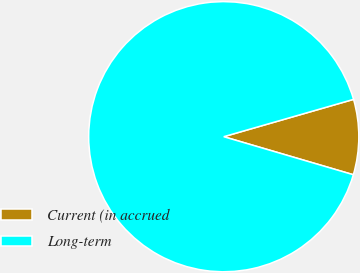<chart> <loc_0><loc_0><loc_500><loc_500><pie_chart><fcel>Current (in accrued<fcel>Long-term<nl><fcel>9.0%<fcel>91.0%<nl></chart> 